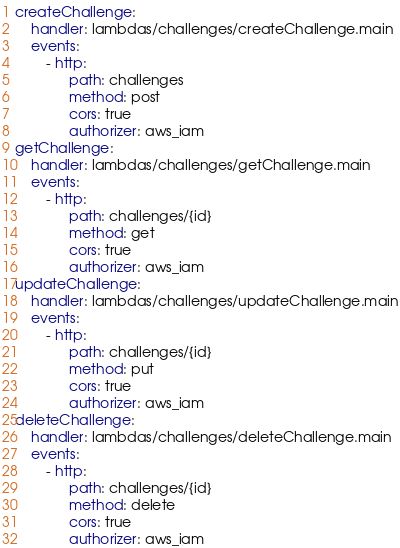<code> <loc_0><loc_0><loc_500><loc_500><_YAML_>createChallenge:
    handler: lambdas/challenges/createChallenge.main
    events:
        - http:
              path: challenges
              method: post
              cors: true
              authorizer: aws_iam
getChallenge:
    handler: lambdas/challenges/getChallenge.main
    events:
        - http:
              path: challenges/{id}
              method: get
              cors: true
              authorizer: aws_iam
updateChallenge:
    handler: lambdas/challenges/updateChallenge.main
    events:
        - http:
              path: challenges/{id}
              method: put
              cors: true
              authorizer: aws_iam
deleteChallenge:
    handler: lambdas/challenges/deleteChallenge.main
    events:
        - http:
              path: challenges/{id}
              method: delete
              cors: true
              authorizer: aws_iam
</code> 